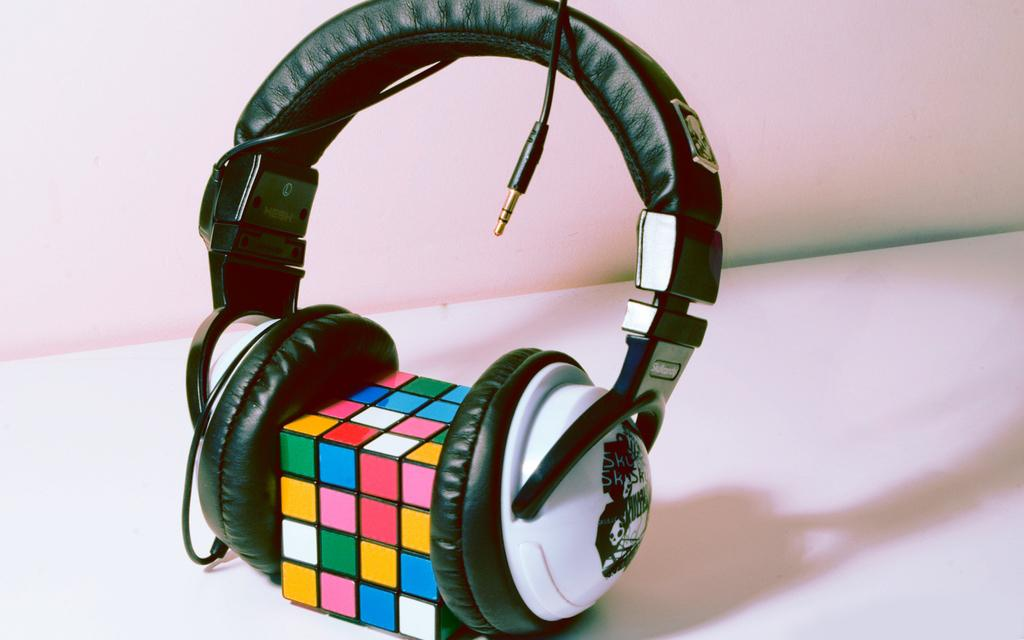What type of audio device is in the image? There is a headphone in the image. What other object can be seen in the image? There is a cube in the image. Where are the headphone and cube located? Both the headphone and cube are on a table. What is visible behind the headphone? There is a wall visible behind the headphone. What type of wax is being used to create the cube? There is no wax present in the image, and the cube is not being created. 